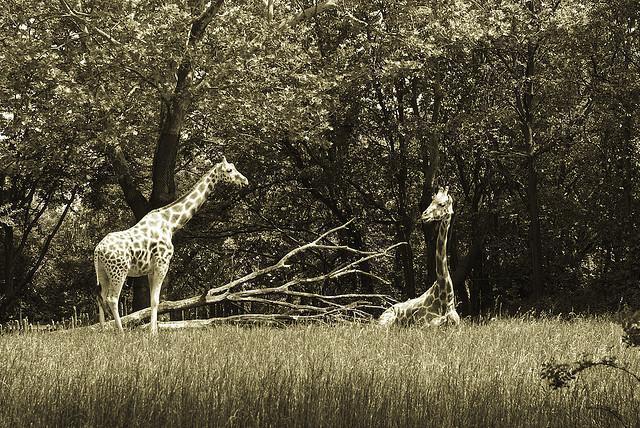How many animals are in this scene?
Give a very brief answer. 2. How many giraffes are in the photo?
Give a very brief answer. 2. 